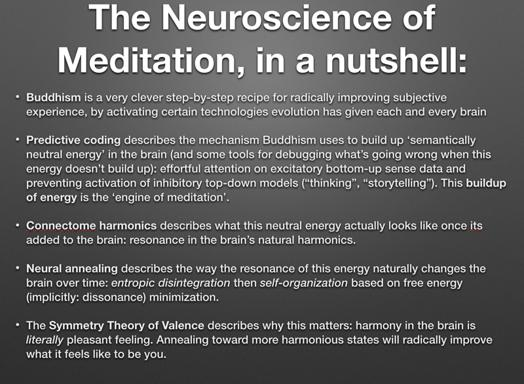What do connectome harmonics describe in this context? In the discussion, connectome harmonics explain the patterns of neural energy distribution and resonance within the brain. It metaphorically illustrates what this 'neutral energy' resembles once integrated into the natural frequency and vibration patterns of the brain's neurological architecture. 